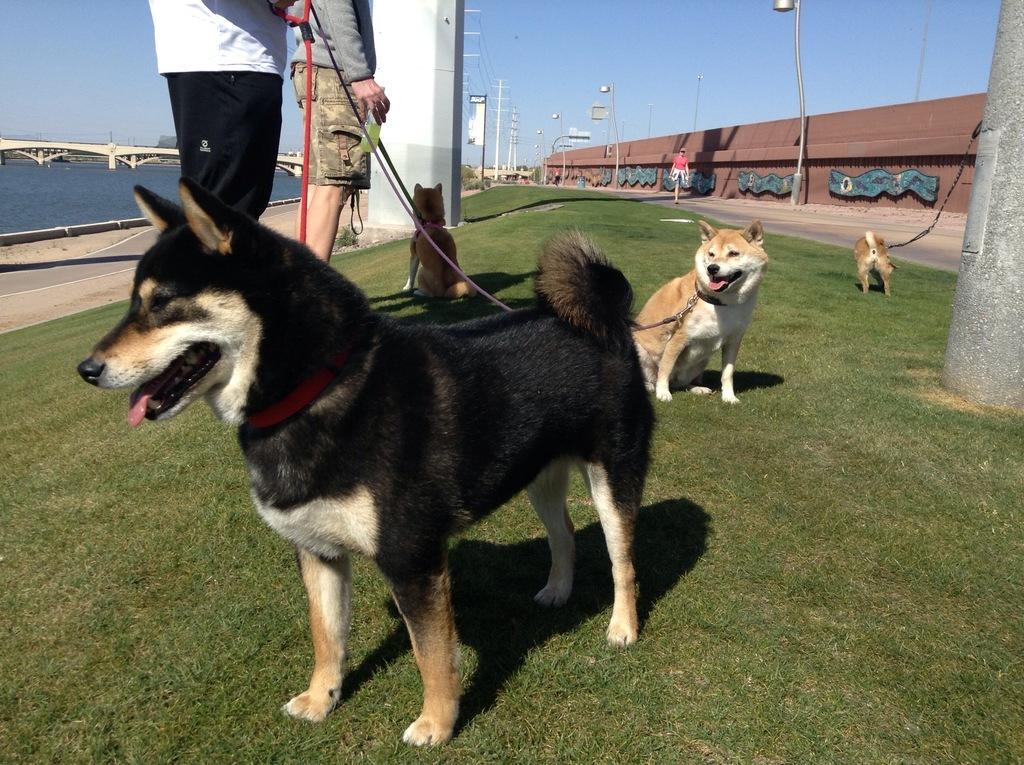Could you give a brief overview of what you see in this image? In this image I can see few dogs. They are in brown,white and black color. I can see two persons standing and holding ropes. Back Side I can see a bridge,water,buildings,light poles,wires,poles. The sky is in blue color. 